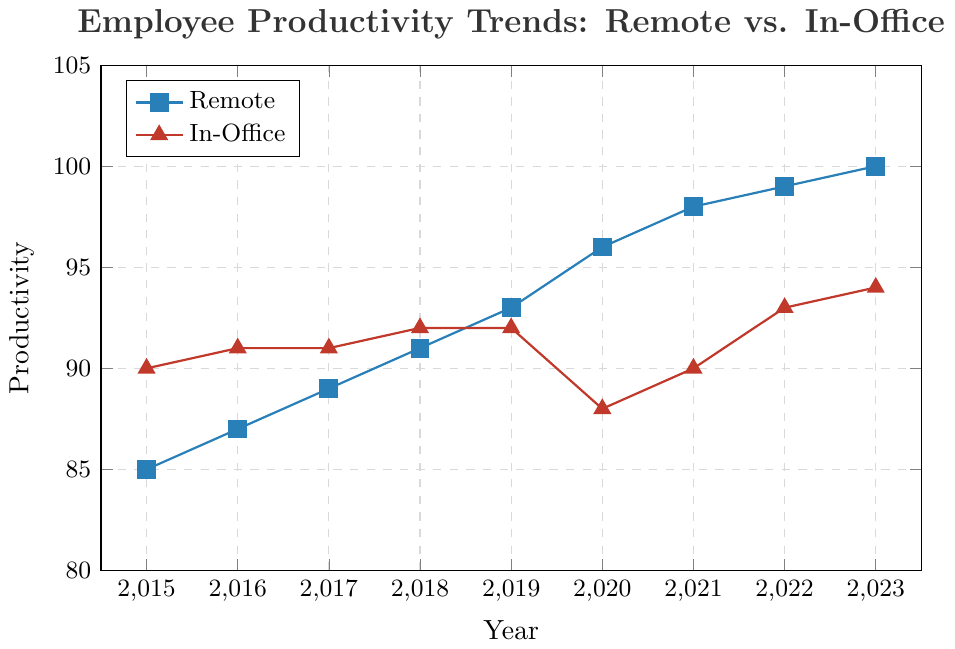What year did remote productivity first surpass in-office productivity? Remote productivity first surpasses in-office productivity in 2020. According to the plot, in 2019, both remote and in-office productivity were equal at 92. In 2020, remote productivity increased to 96, while in-office productivity decreased to 88.
Answer: 2020 What's the difference in productivity between remote and in-office work in 2023? In 2023, the remote productivity is 100 and the in-office productivity is 94. The difference is calculated as 100 - 94 = 6.
Answer: 6 How did remote productivity change between 2015 and 2023? To find the change, we subtract the productivity in 2015 from the productivity in 2023 for remote work. That is 100 - 85 = 15.
Answer: 15 Which environment showed the largest single-year increase in productivity? To find the largest single-year increase, we look at the differences between years for each work environment. For remote, 2020-2019 is the largest increase (96 - 93 = 3). For in-office, 2022-2021 is the largest increase (93 - 90 = 3). Both environments had their largest single-year increase of 3 points.
Answer: Both Remote & In-Office In what year did in-office productivity reach its minimum value from 2015 to 2023? From the plot, the minimum in-office productivity occurred in 2020, which was 88.
Answer: 2020 What's the average productivity for remote work from 2015 to 2023? Adding all the yearly productivity values for remote work (85, 87, 89, 91, 93, 96, 98, 99, 100) gives a total of 738. There are 9 years, so the average is 738 / 9 = 82.
Answer: 82 